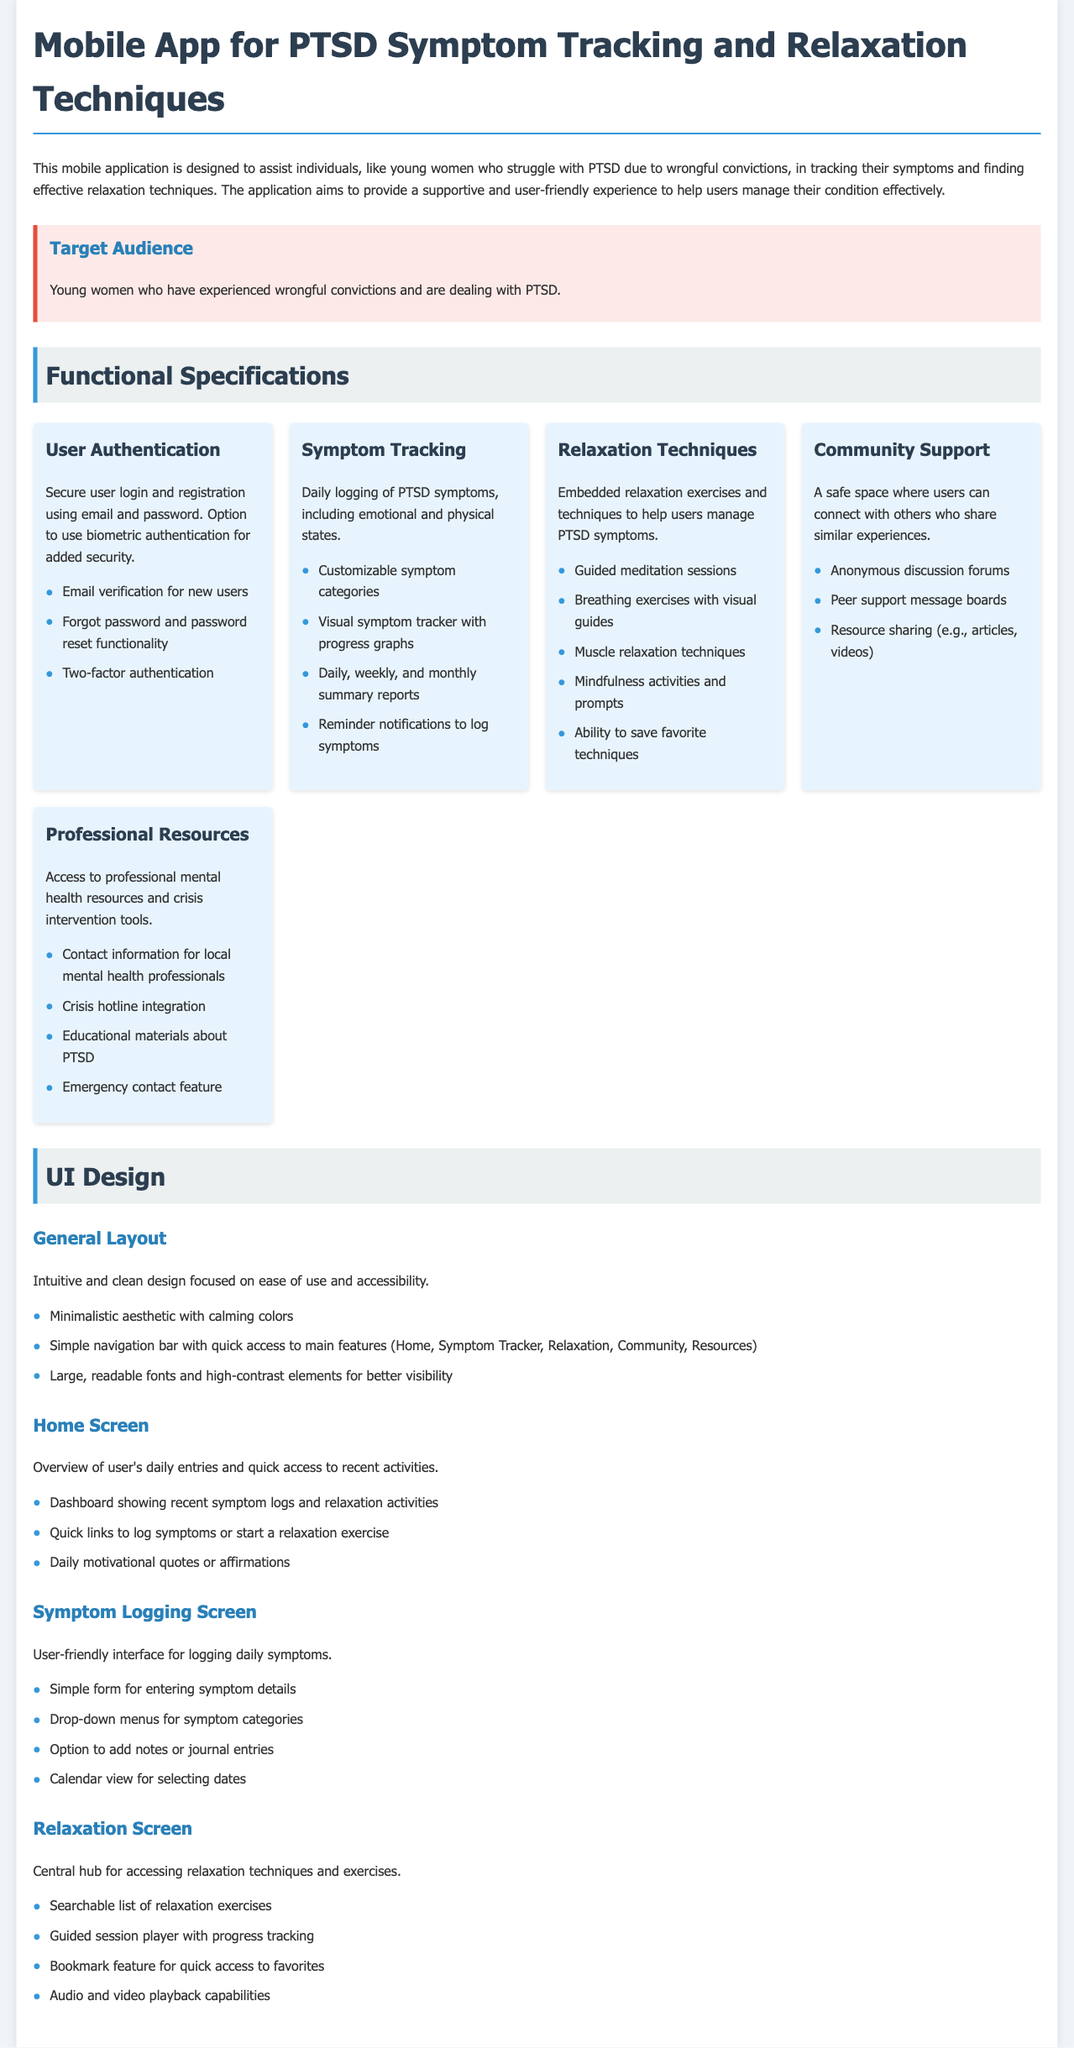what is the title of the document? The title of the document is provided at the top of the specification sheet.
Answer: Mobile App for PTSD Symptom Tracking and Relaxation Techniques who is the target audience of the app? The target audience section specifies the intended users of the app.
Answer: Young women who have experienced wrongful convictions and are dealing with PTSD how many functions are listed under Functional Specifications? The document lists a number of features under the Functional Specifications section.
Answer: Five what is included in the Symptom Tracking feature? The symptom tracking feature includes several functionalities that help users log their symptoms.
Answer: Daily logging of PTSD symptoms, including emotional and physical states which relaxation technique allows saving preferences? One of the relaxation techniques features allows users to personalize their experience.
Answer: Ability to save favorite techniques what is the main focus of the UI design? The general layout section describes the primary design approach for the app's user interface.
Answer: Ease of use and accessibility how many relaxation exercises are embedded in the app? The document lists specific relaxation techniques available in the app.
Answer: Five what is the purpose of the Community Support feature? The Community Support feature is aimed at creating a supportive environment for users.
Answer: A safe space where users can connect with others who share similar experiences 